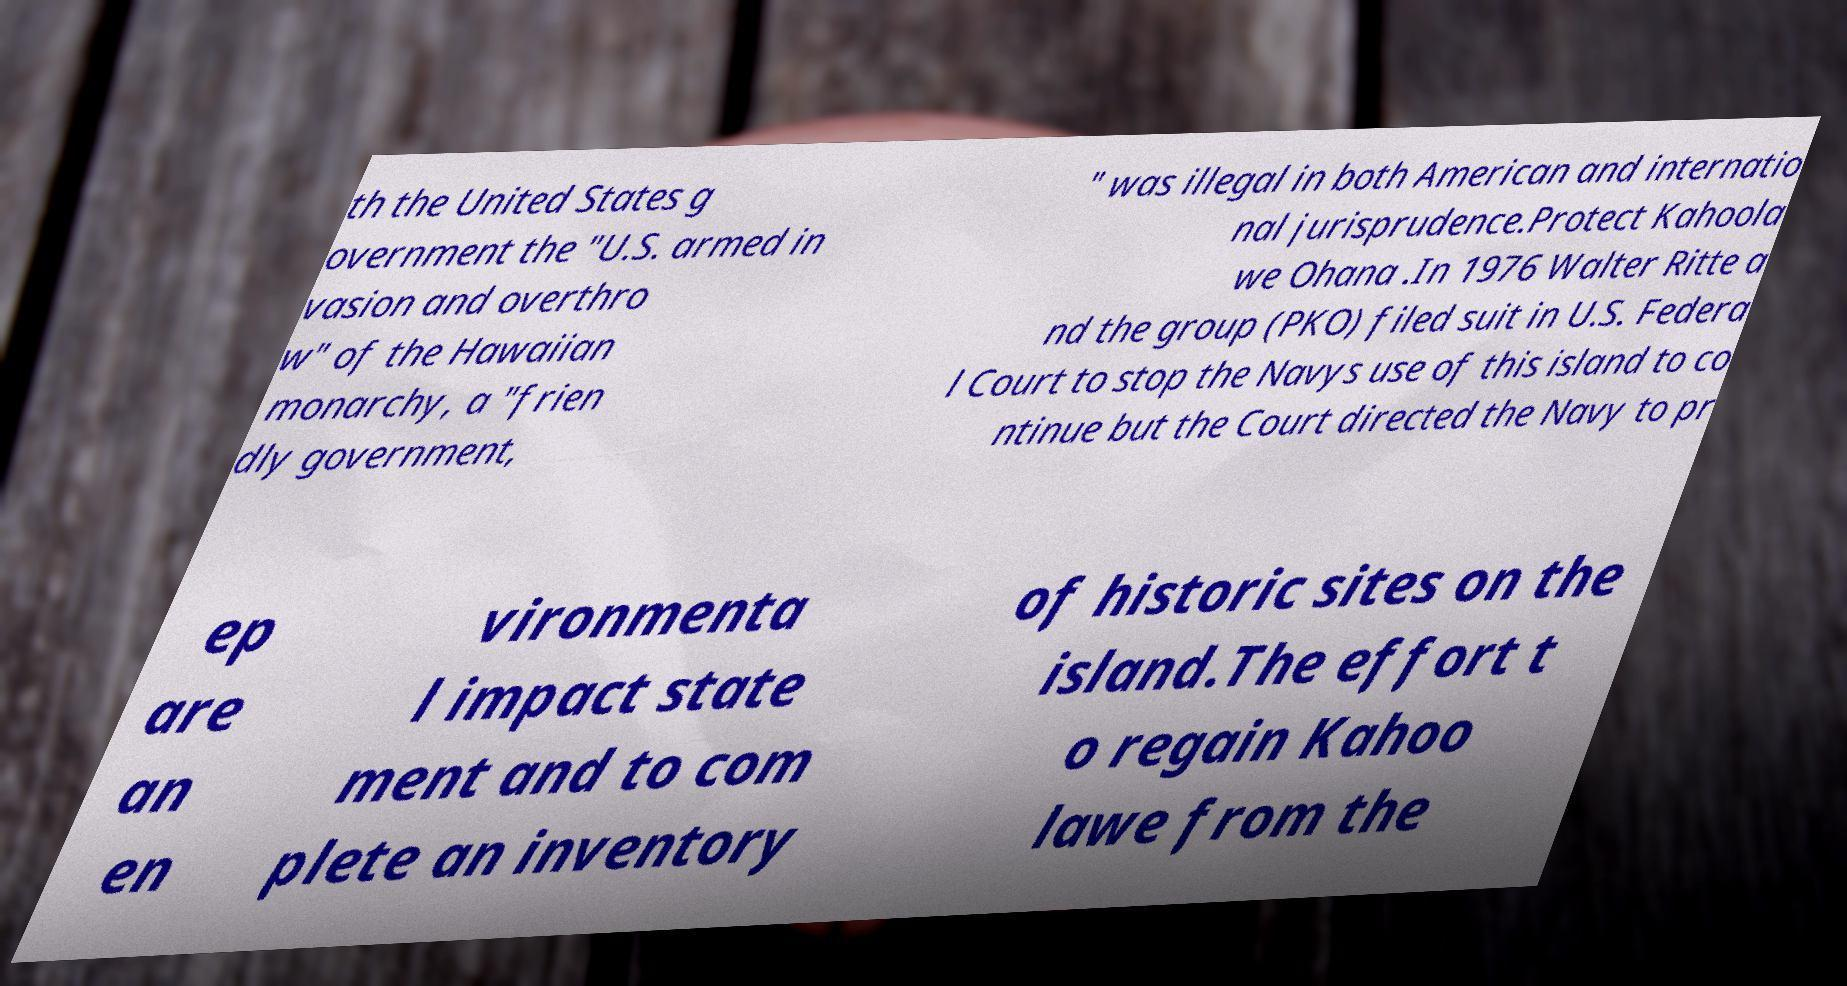Can you accurately transcribe the text from the provided image for me? th the United States g overnment the "U.S. armed in vasion and overthro w" of the Hawaiian monarchy, a "frien dly government, " was illegal in both American and internatio nal jurisprudence.Protect Kahoola we Ohana .In 1976 Walter Ritte a nd the group (PKO) filed suit in U.S. Federa l Court to stop the Navys use of this island to co ntinue but the Court directed the Navy to pr ep are an en vironmenta l impact state ment and to com plete an inventory of historic sites on the island.The effort t o regain Kahoo lawe from the 